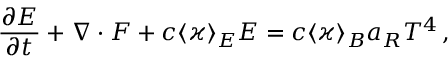Convert formula to latex. <formula><loc_0><loc_0><loc_500><loc_500>\frac { \partial E } { \partial t } + \nabla \cdot F + c \langle \varkappa \rangle _ { E } E = c \langle \varkappa \rangle _ { B } a _ { R } T ^ { 4 } \, ,</formula> 